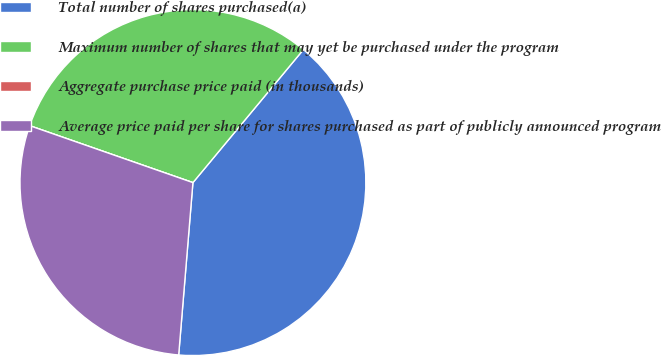<chart> <loc_0><loc_0><loc_500><loc_500><pie_chart><fcel>Total number of shares purchased(a)<fcel>Maximum number of shares that may yet be purchased under the program<fcel>Aggregate purchase price paid (in thousands)<fcel>Average price paid per share for shares purchased as part of publicly announced program<nl><fcel>40.28%<fcel>30.69%<fcel>0.0%<fcel>29.03%<nl></chart> 